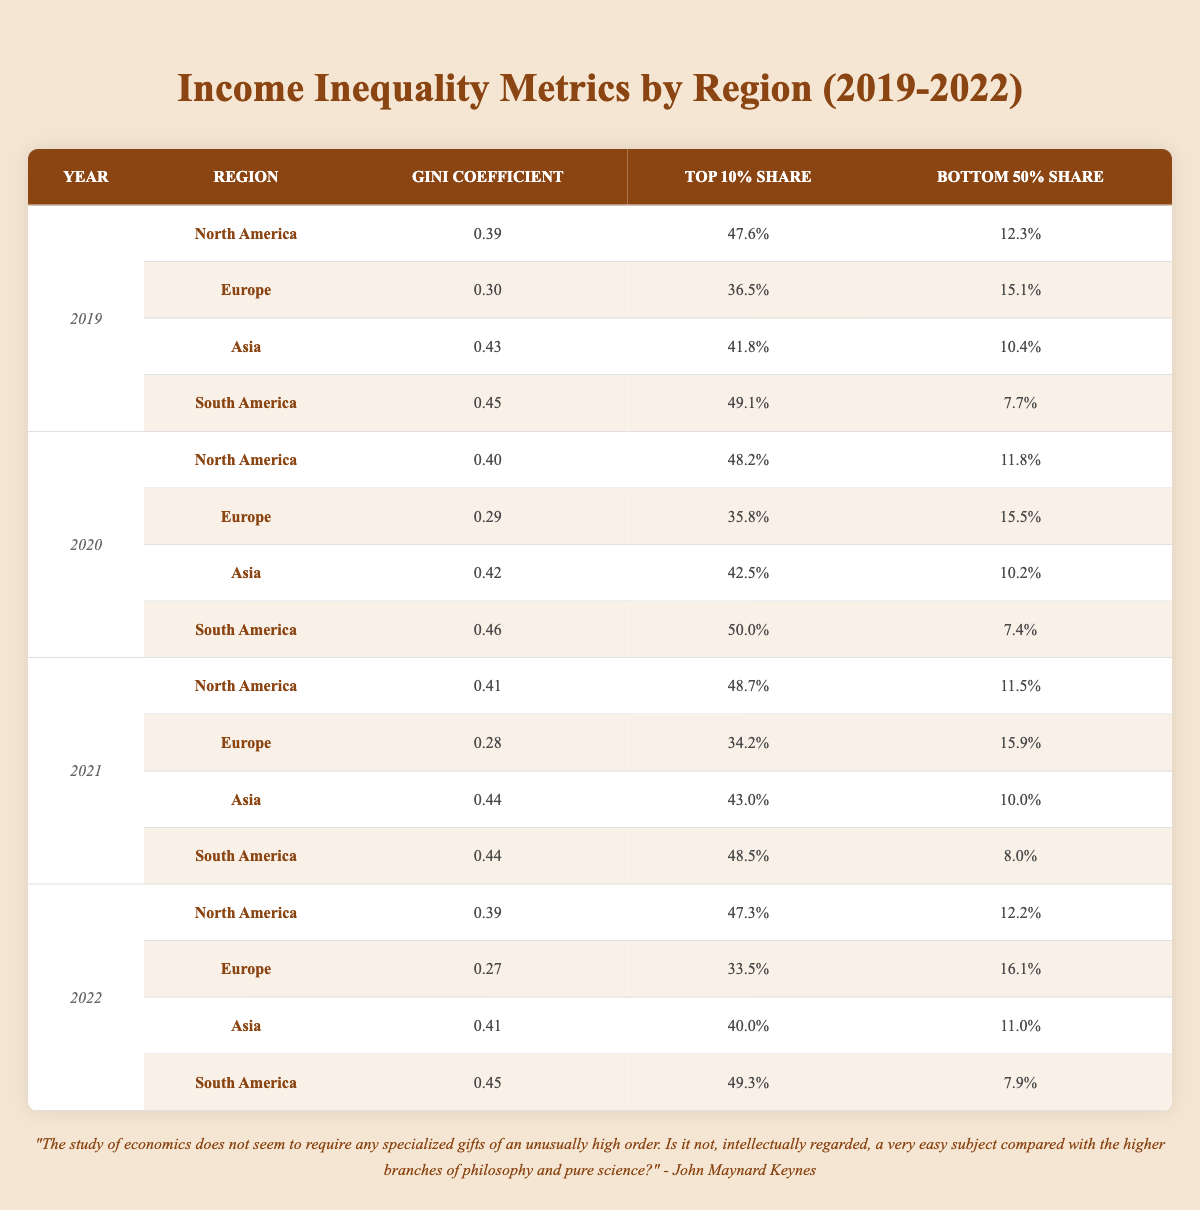What was the Gini coefficient for North America in 2021? The Gini coefficient for North America in 2021 can be found in the row corresponding to that year and region. It shows a value of 0.41.
Answer: 0.41 Which region had the highest Top 10% share in 2020? By examining the Top 10% Share column for 2020, South America shows the highest share at 50.0%.
Answer: South America Was the Gini coefficient for Europe higher in 2019 or 2022? Comparing the Gini coefficient values for Europe in 2019 (0.30) and 2022 (0.27), it is evident that 0.30 is higher than 0.27.
Answer: Yes What is the difference in Gini coefficient between Asia in 2019 and North America in 2020? The Gini coefficient for Asia in 2019 is 0.43 and for North America in 2020 is 0.40. The difference is calculated as 0.43 - 0.40 = 0.03.
Answer: 0.03 What was the average Top 10% share across all regions in 2021? To calculate the average, sum the Top 10% shares for all regions in 2021: (48.7 + 34.2 + 43.0 + 48.5) = 174.4. Then divide by 4 (the number of regions): 174.4 / 4 = 43.6.
Answer: 43.6 Is the Bottom 50% share for South America in 2020 less than that in 2021? The Bottom 50% share for South America in 2020 is 7.4% and in 2021 it is 8.0%. Since 7.4% is less than 8.0%, the answer is yes.
Answer: Yes What trends can be observed in the Gini coefficients from 2019 to 2022 for North America? Observing the Gini coefficients for North America from 2019 to 2022: 0.39 (2019), 0.40 (2020), 0.41 (2021), 0.39 (2022). The trend shows a slight increase until 2021, followed by a decrease in 2022.
Answer: Increase to 2021, then decrease What is the median Bottom 50% share across all regions in 2022? For 2022, the Bottom 50% shares are as follows: 12.2% (North America), 16.1% (Europe), 11.0% (Asia), and 7.9% (South America). Arranging these values in increasing order: 7.9%, 11.0%, 12.2%, 16.1%. The median is the average of the two middle values: (11.0 + 12.2) / 2 = 11.6.
Answer: 11.6 